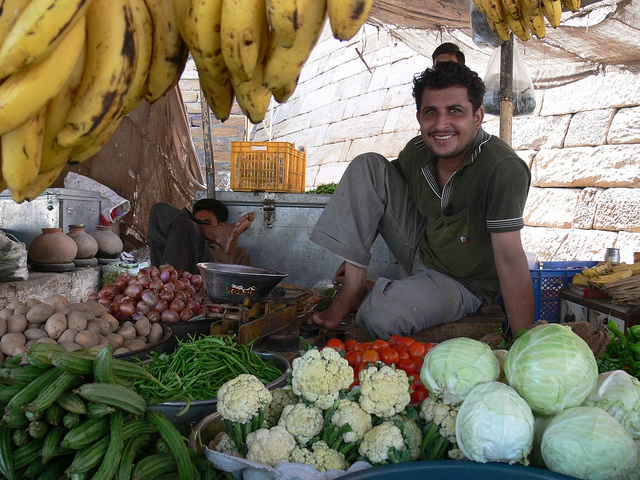Describe the objects in this image and their specific colors. I can see people in olive, black, gray, and maroon tones, banana in olive and maroon tones, banana in olive and tan tones, banana in olive, tan, and maroon tones, and people in olive, black, maroon, and gray tones in this image. 